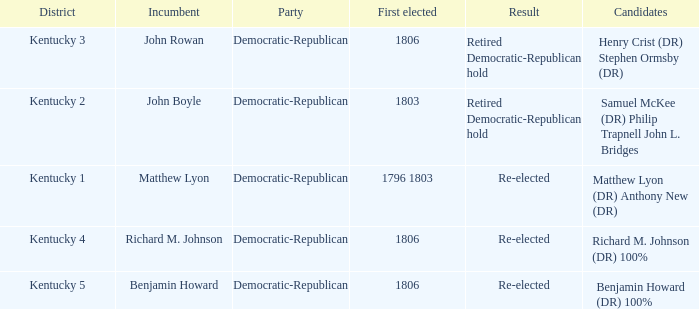Name the number of first elected for kentucky 3 1.0. 